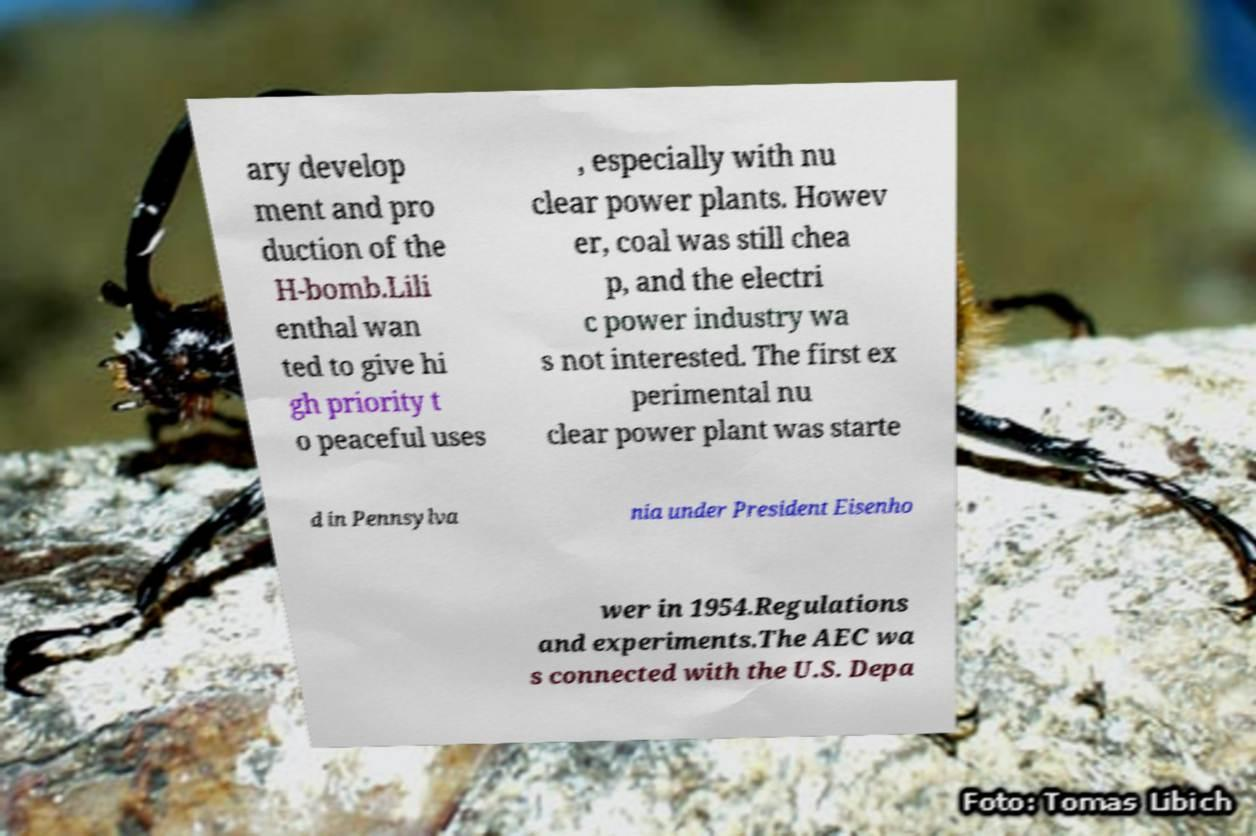Can you accurately transcribe the text from the provided image for me? ary develop ment and pro duction of the H-bomb.Lili enthal wan ted to give hi gh priority t o peaceful uses , especially with nu clear power plants. Howev er, coal was still chea p, and the electri c power industry wa s not interested. The first ex perimental nu clear power plant was starte d in Pennsylva nia under President Eisenho wer in 1954.Regulations and experiments.The AEC wa s connected with the U.S. Depa 